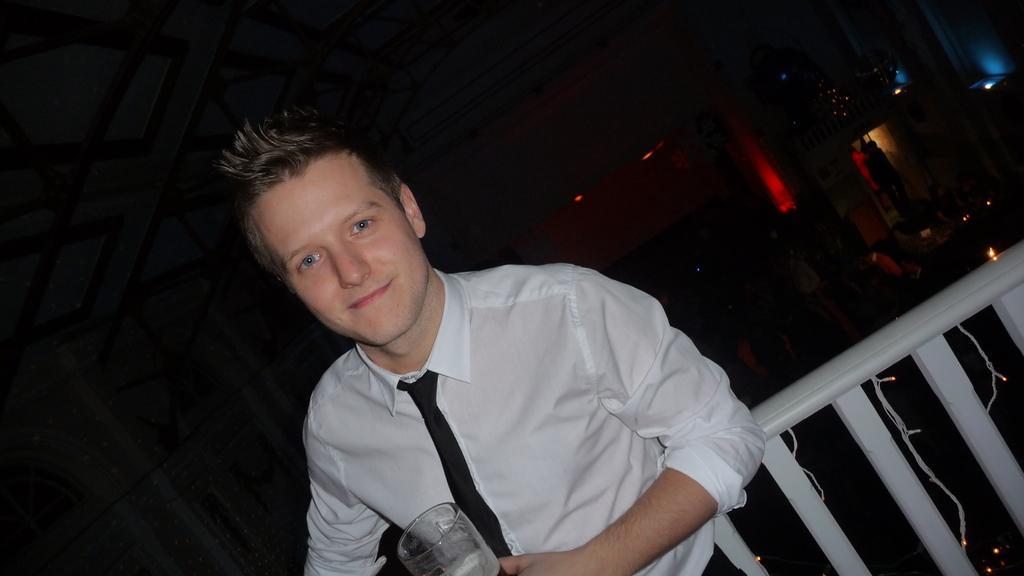Could you give a brief overview of what you see in this image? In the center of the image there is a person wearing a white color shirt and holding glass in his hand. Behind him there is a white color fencing. In the background of the image there is a wall. There is a door. At the top of the image there is ceiling. 